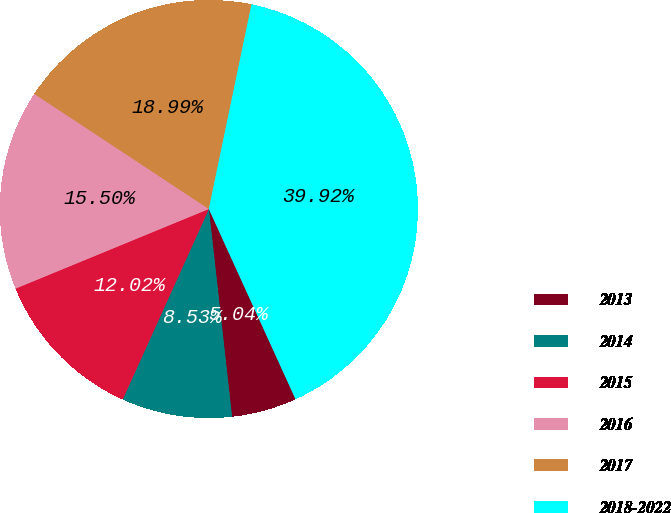<chart> <loc_0><loc_0><loc_500><loc_500><pie_chart><fcel>2013<fcel>2014<fcel>2015<fcel>2016<fcel>2017<fcel>2018-2022<nl><fcel>5.04%<fcel>8.53%<fcel>12.02%<fcel>15.5%<fcel>18.99%<fcel>39.92%<nl></chart> 